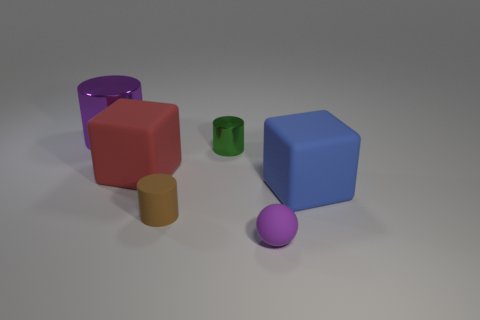There is a metal object that is the same color as the ball; what size is it?
Offer a very short reply. Large. There is a cylinder that is made of the same material as the ball; what is its color?
Make the answer very short. Brown. How many objects are large things to the right of the large purple metallic cylinder or purple shiny cylinders?
Ensure brevity in your answer.  3. What size is the purple object on the right side of the small brown matte cylinder?
Keep it short and to the point. Small. Is the size of the purple cylinder the same as the matte block that is on the left side of the large blue block?
Keep it short and to the point. Yes. What color is the cube to the left of the large cube that is on the right side of the small brown thing?
Offer a terse response. Red. What number of other things are the same color as the ball?
Provide a succinct answer. 1. The purple shiny thing is what size?
Ensure brevity in your answer.  Large. Is the number of tiny shiny cylinders that are behind the tiny rubber cylinder greater than the number of small brown objects in front of the purple rubber thing?
Offer a very short reply. Yes. There is a brown rubber thing right of the red object; what number of tiny green things are behind it?
Provide a succinct answer. 1. 